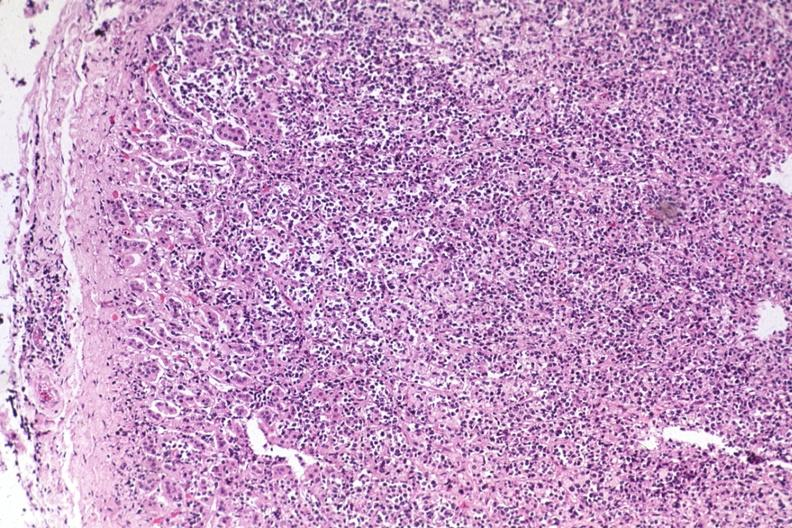what does this image show?
Answer the question using a single word or phrase. Diffuse infiltrate 